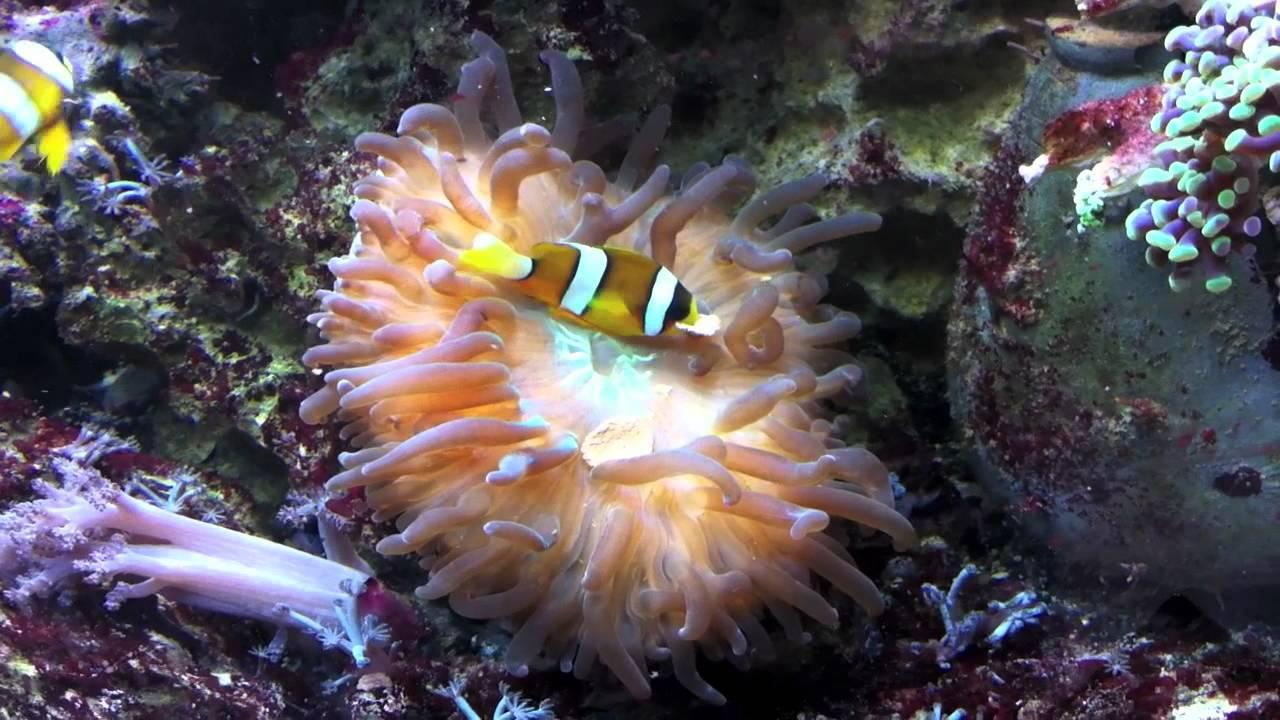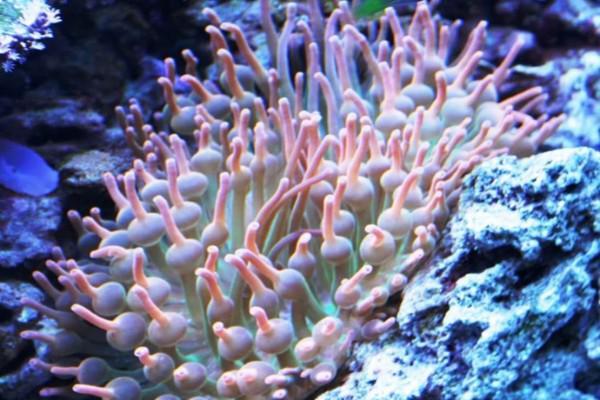The first image is the image on the left, the second image is the image on the right. Evaluate the accuracy of this statement regarding the images: "In one image, there is a black and white striped fish visible near a sea anemone". Is it true? Answer yes or no. No. The first image is the image on the left, the second image is the image on the right. Evaluate the accuracy of this statement regarding the images: "The right image shows a pinkish anemone with a fish in its tendrils.". Is it true? Answer yes or no. No. 